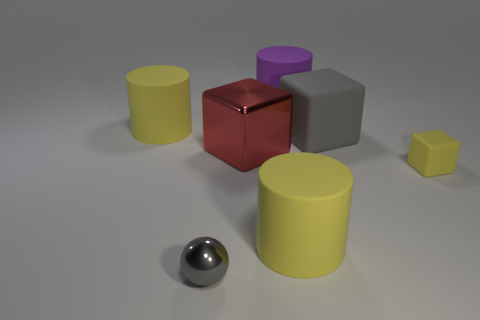How many other large red objects are the same shape as the big red metallic object? There are no other large red objects in the image that are the same shape as the big red metallic cube. 